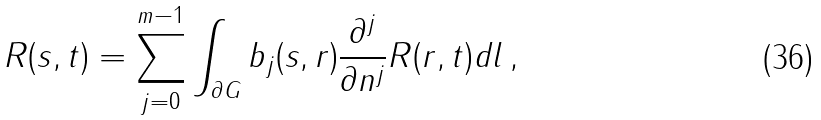<formula> <loc_0><loc_0><loc_500><loc_500>R ( s , t ) = \sum _ { j = 0 } ^ { m - 1 } \int _ { \partial G } b _ { j } ( s , r ) \frac { \partial ^ { j } } { \partial n ^ { j } } R ( r , t ) d l \, ,</formula> 